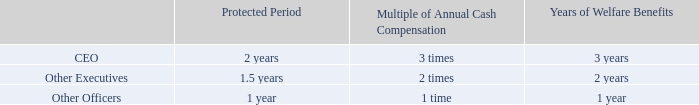COMPENSATION DISCUSSION AND ANALYSIS
IV. Our 2019 Compensation Program and Components of Pay The table below shows (i) the length of the “protected period” afforded to officers following a change of control and (ii) the multiple of salary and bonus payment and years of welfare benefits to which officers will be entitled if change of control benefits become payable under our agreements and related policies:
For more information on change of control arrangements applicable to our executives, including our rationale for
providing these benefits, see “Executive Compensation—Potential Termination Payments—Payments Made
Upon a Change of Control.” For information on change of control severance benefits payable to our junior
officers and managers, see “—Severance Benefits” in the next subsection below.
What does 'Protected Period' in the table refer to? “protected period” afforded to officers following a change of control. Under what conditions would officers be entitled to the years of welfare benefits? If change of control benefits become payable under our agreements and related policies. Which types of officers are listed in the table? Ceo, other executives, other officers. Which type of officer has the longest protected period? 2>1.5>1
Answer: ceo. What is the difference in the protected period between CEO and Other Executives? 2-1.5
Answer: 0.5. What is the average protected period? (2+1.5+1)/3
Answer: 1.5. 